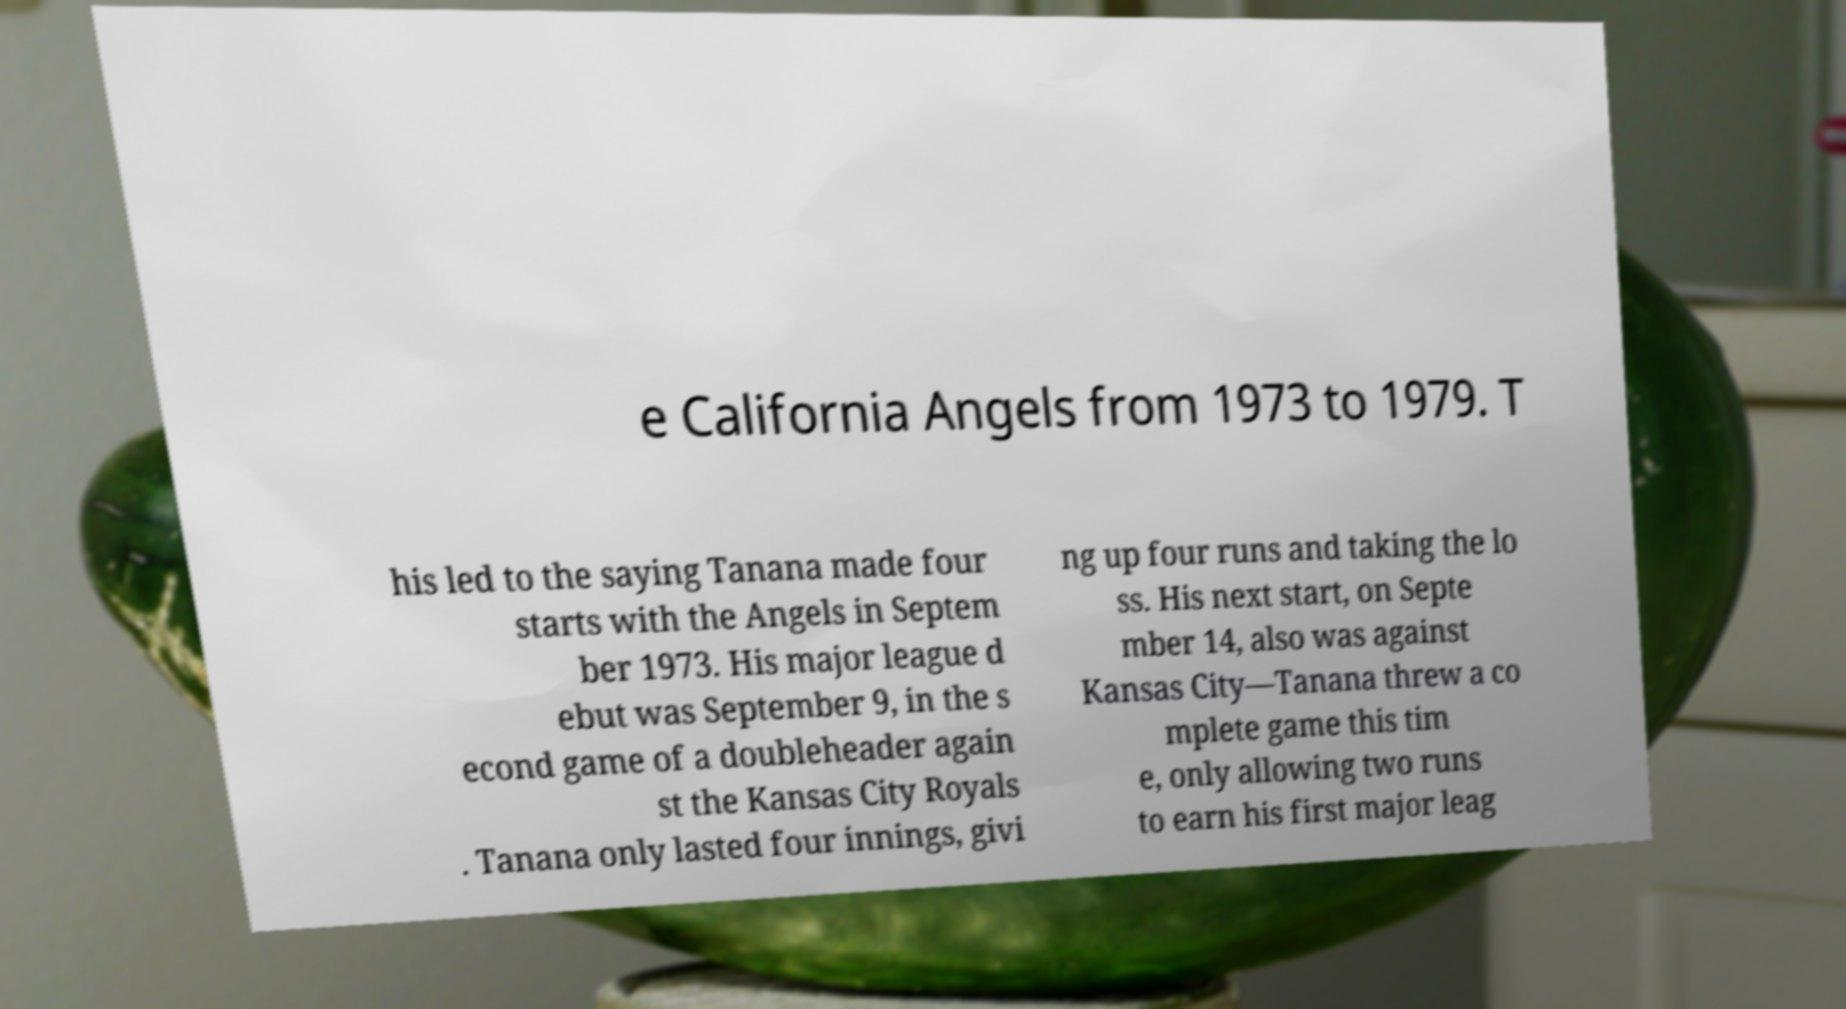Could you extract and type out the text from this image? e California Angels from 1973 to 1979. T his led to the saying Tanana made four starts with the Angels in Septem ber 1973. His major league d ebut was September 9, in the s econd game of a doubleheader again st the Kansas City Royals . Tanana only lasted four innings, givi ng up four runs and taking the lo ss. His next start, on Septe mber 14, also was against Kansas City—Tanana threw a co mplete game this tim e, only allowing two runs to earn his first major leag 